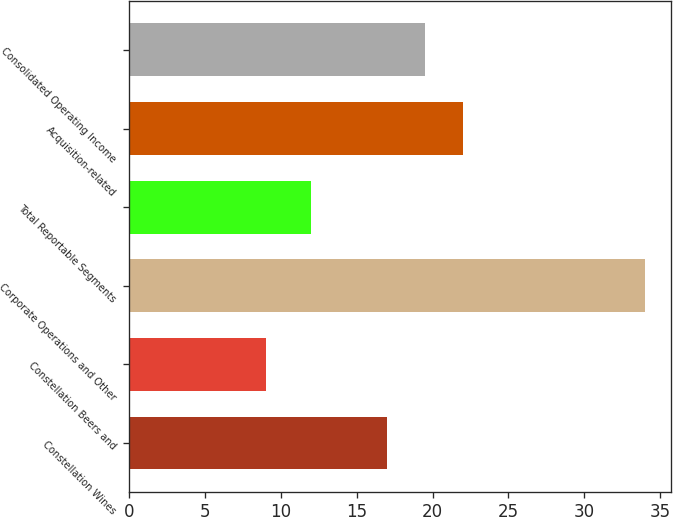Convert chart to OTSL. <chart><loc_0><loc_0><loc_500><loc_500><bar_chart><fcel>Constellation Wines<fcel>Constellation Beers and<fcel>Corporate Operations and Other<fcel>Total Reportable Segments<fcel>Acquisition-related<fcel>Consolidated Operating Income<nl><fcel>17<fcel>9<fcel>34<fcel>12<fcel>22<fcel>19.5<nl></chart> 